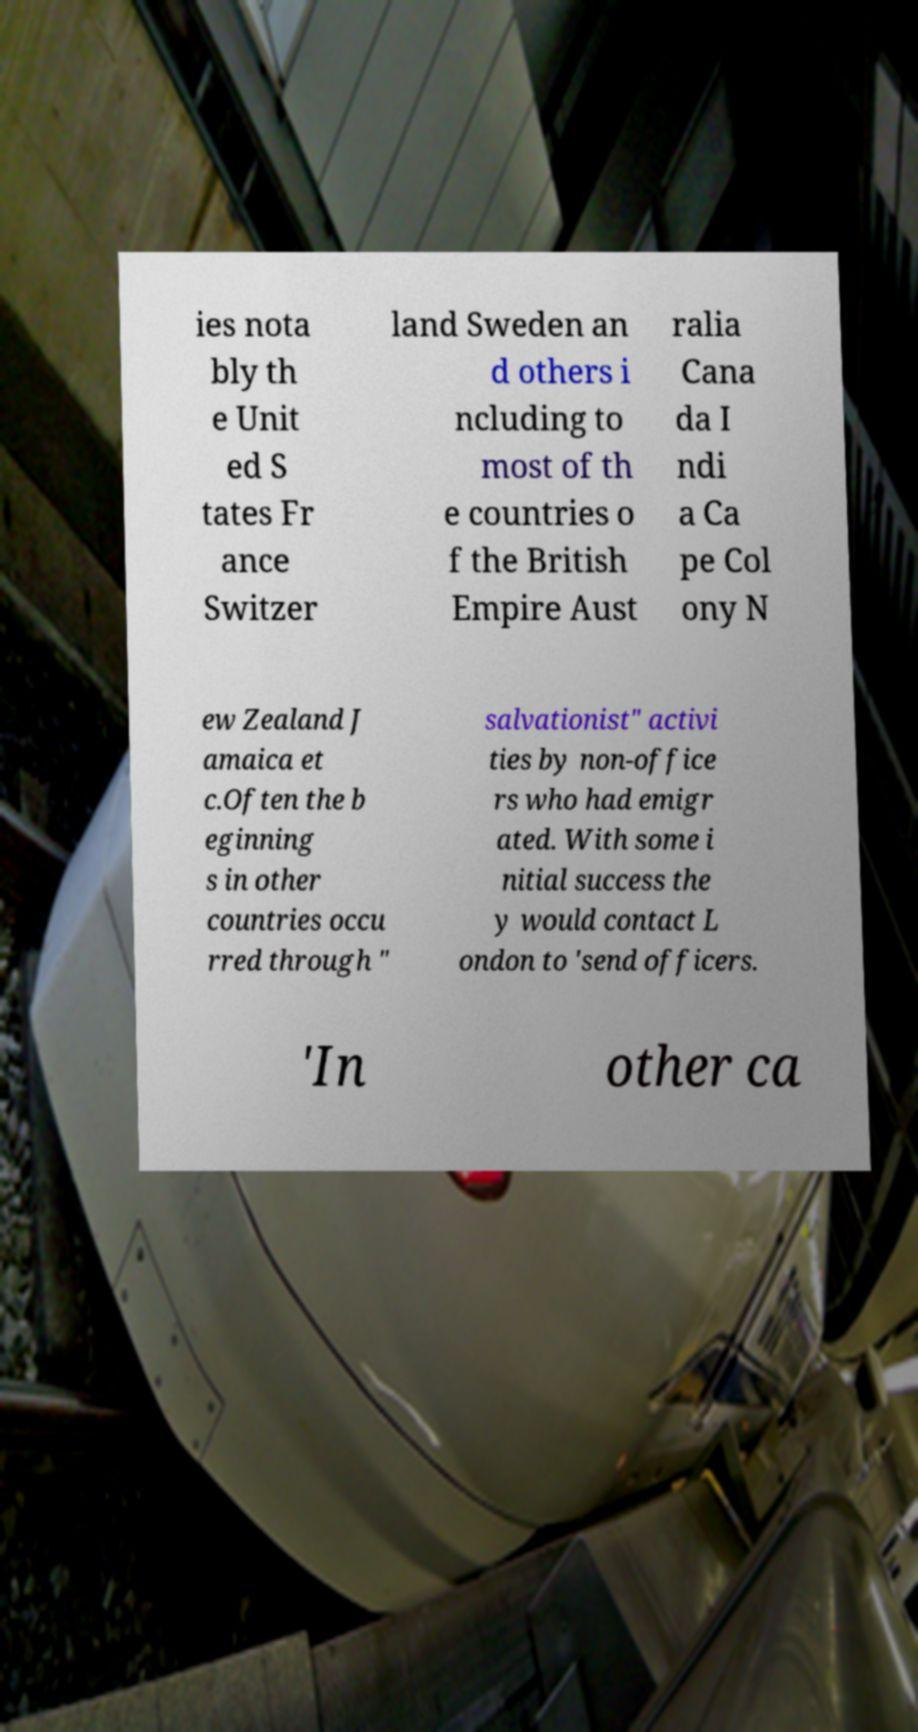Could you extract and type out the text from this image? ies nota bly th e Unit ed S tates Fr ance Switzer land Sweden an d others i ncluding to most of th e countries o f the British Empire Aust ralia Cana da I ndi a Ca pe Col ony N ew Zealand J amaica et c.Often the b eginning s in other countries occu rred through " salvationist" activi ties by non-office rs who had emigr ated. With some i nitial success the y would contact L ondon to 'send officers. 'In other ca 